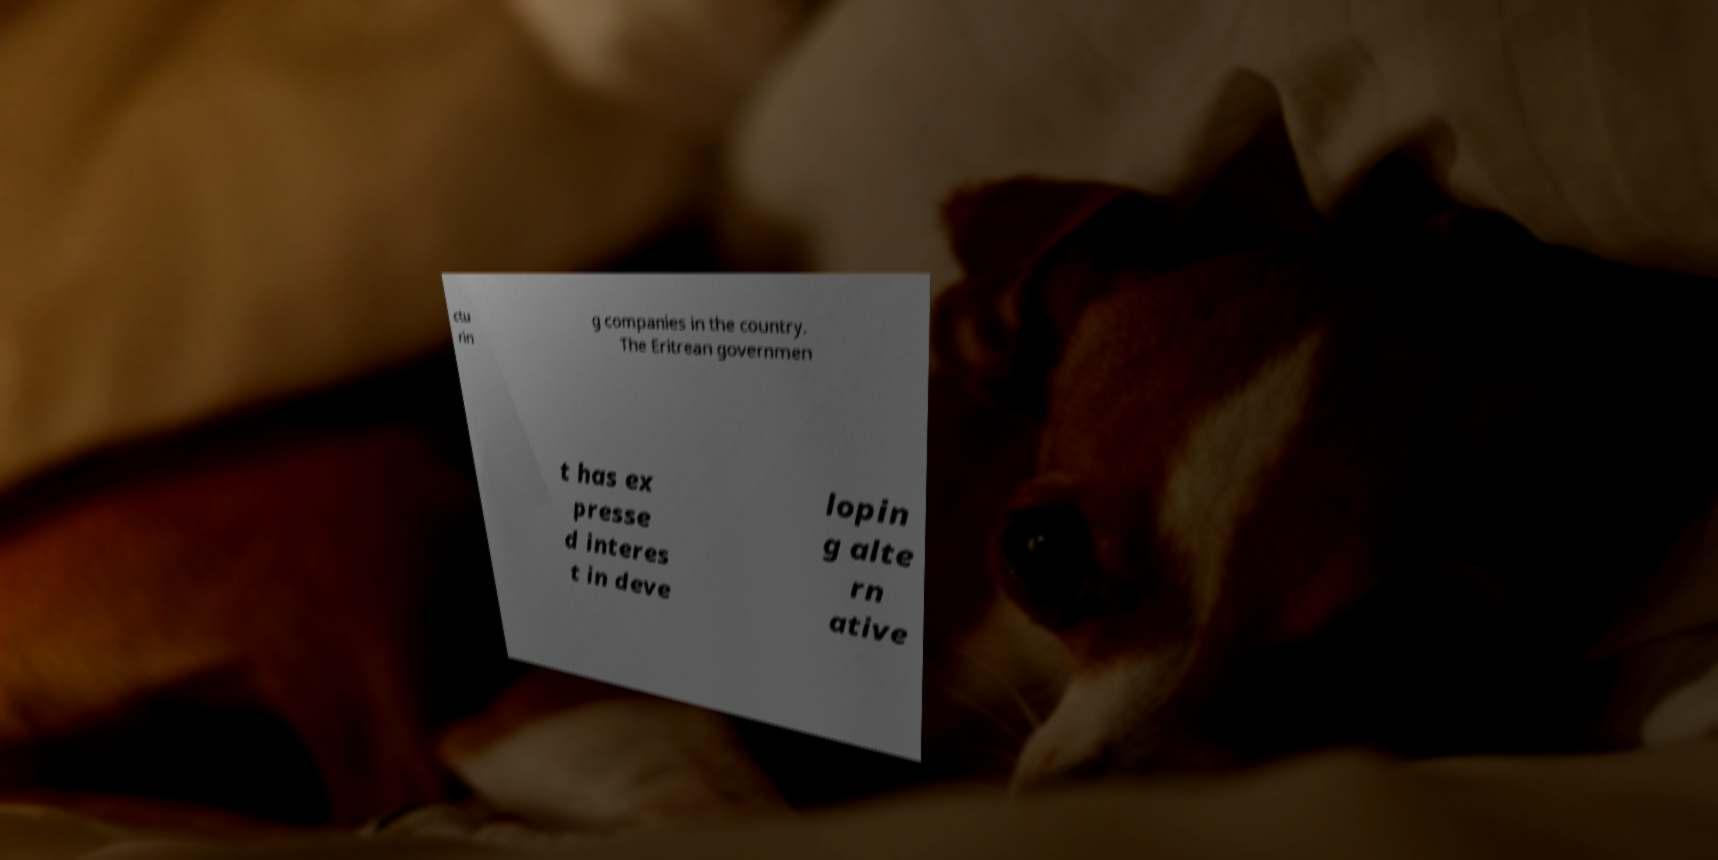There's text embedded in this image that I need extracted. Can you transcribe it verbatim? ctu rin g companies in the country. The Eritrean governmen t has ex presse d interes t in deve lopin g alte rn ative 